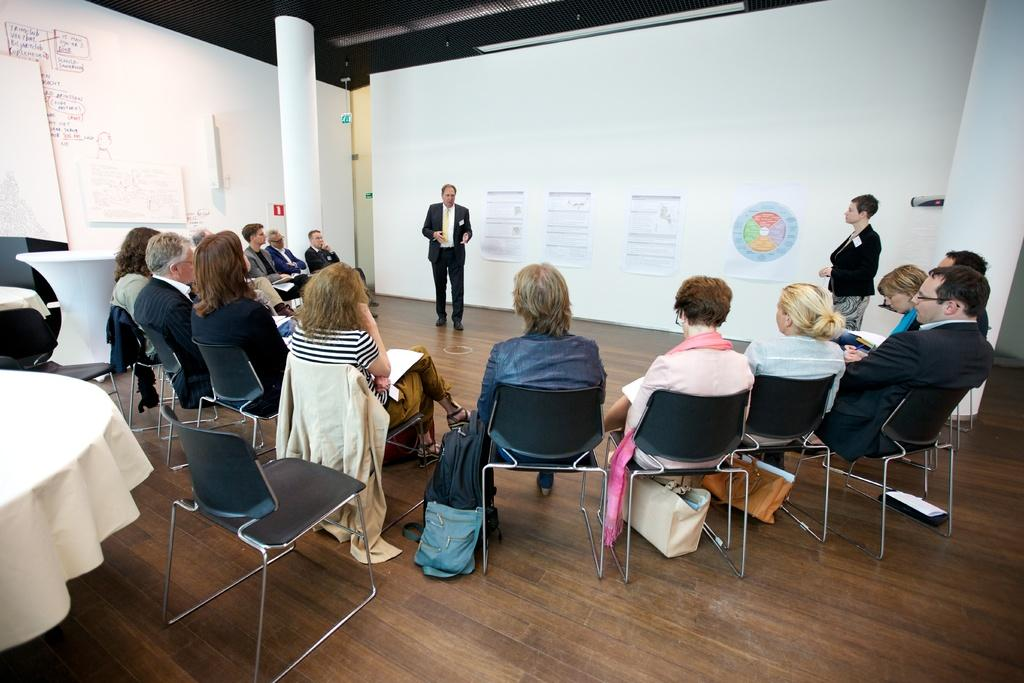What is the arrangement of the people in the image? There is a group of people sitting in a semicircle in the image. What are the two people standing doing? The two people standing are explaining to the group. What can be seen on the wall in the background? There are posters on the wall in the background. What type of hate can be seen on the faces of the people in the image? There is no hate visible on the faces of the people in the image; they appear to be engaged in a discussion or presentation. What kind of watch is the person in the image wearing? There is no watch visible on any person in the image. 